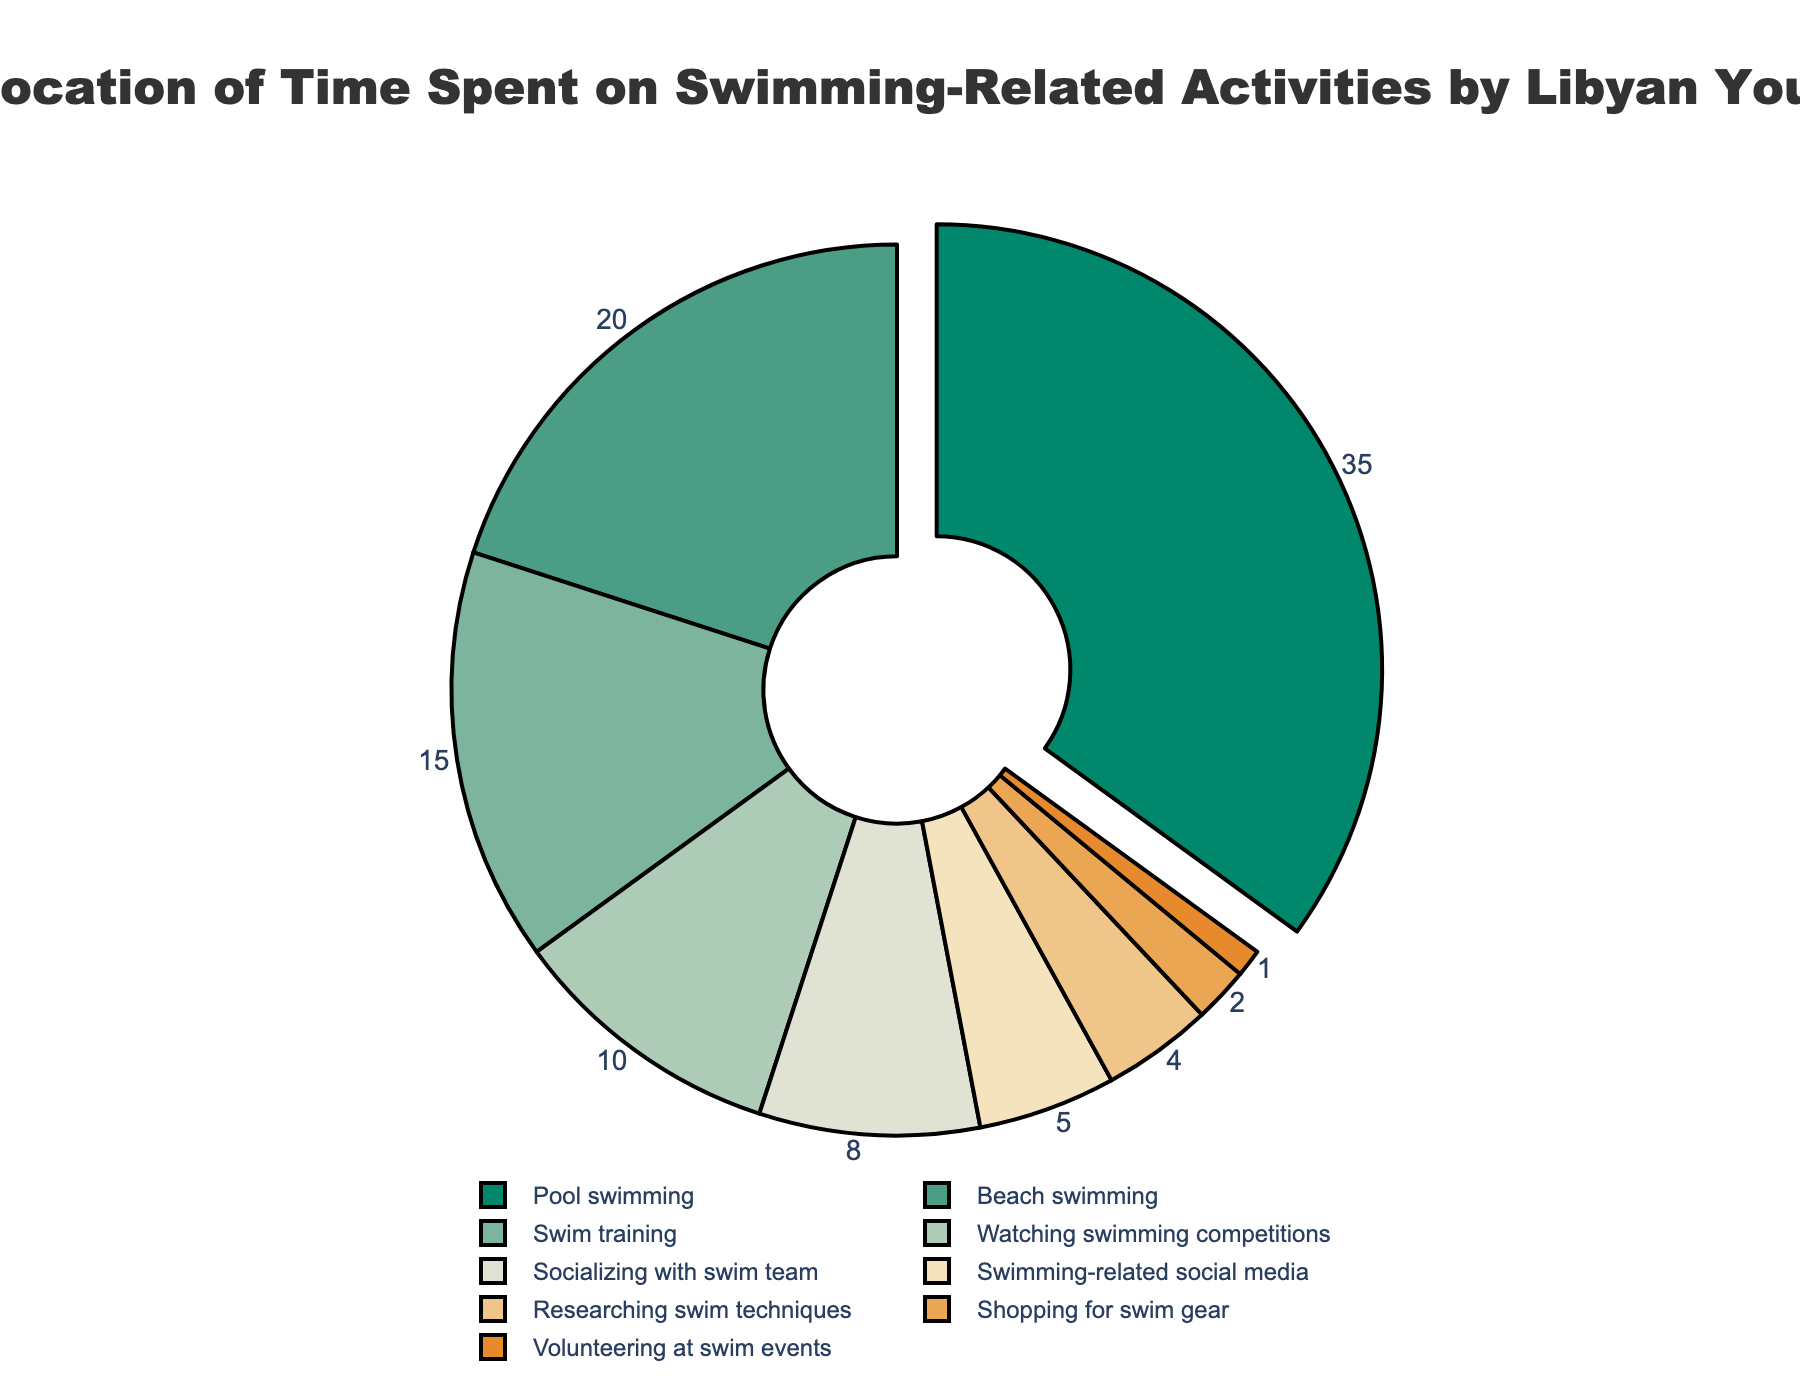What percentage of time is spent on pool swimming? The figure shows that pool swimming accounts for 35% of the total time spent on swimming-related activities by Libyan youth.
Answer: 35% Which activity uses more time, beach swimming or swim training? The figure shows that beach swimming uses 20% of the time and swim training uses 15%. Since 20% is greater than 15%, beach swimming uses more time than swim training.
Answer: Beach swimming How much more time is spent on socializing with the swim team compared to shopping for swim gear? From the figure, socializing with the swim team accounts for 8% while shopping for swim gear accounts for 2%. The difference is 8% - 2% = 6%.
Answer: 6% What is the least time-consuming activity? The figure shows that volunteering at swim events is the least time-consuming activity, accounting for 1% of the total time.
Answer: Volunteering at swim events What is the total percentage of time spent on swimming-related social media, researching swim techniques, and shopping for swim gear? The figure shows the percentages as follows: swimming-related social media (5%), researching swim techniques (4%), and shopping for swim gear (2%). The total is 5% + 4% + 2% = 11%.
Answer: 11% Which color represents beach swimming in the chart? The slice representing beach swimming is colored green.
Answer: Green Is the percentage of time spent on watching swimming competitions greater than or less than the time spent on training? The figure shows 10% for watching swimming competitions and 15% for training. Since 10% is less than 15%, watching swimming competitions takes less time than training.
Answer: Less than Which activities together account for more than half of the total time? The figure shows that pool swimming (35%) and beach swimming (20%) together account for 35% + 20% = 55%, which is more than half of the total time.
Answer: Pool swimming and beach swimming If another activity accounted for an additional 5% of the time, what would be the new percentage for pool swimming? Currently, pool swimming accounts for 35%. Adding another activity that takes 5% would keep the percentage for pool swimming the same because each activity percentage is independent.
Answer: 35% How much time is spent on activities other than pool swimming and beach swimming? Pool swimming accounts for 35%, and beach swimming accounts for 20%. Other activities account for 100% - (35% + 20%) = 45%.
Answer: 45% 